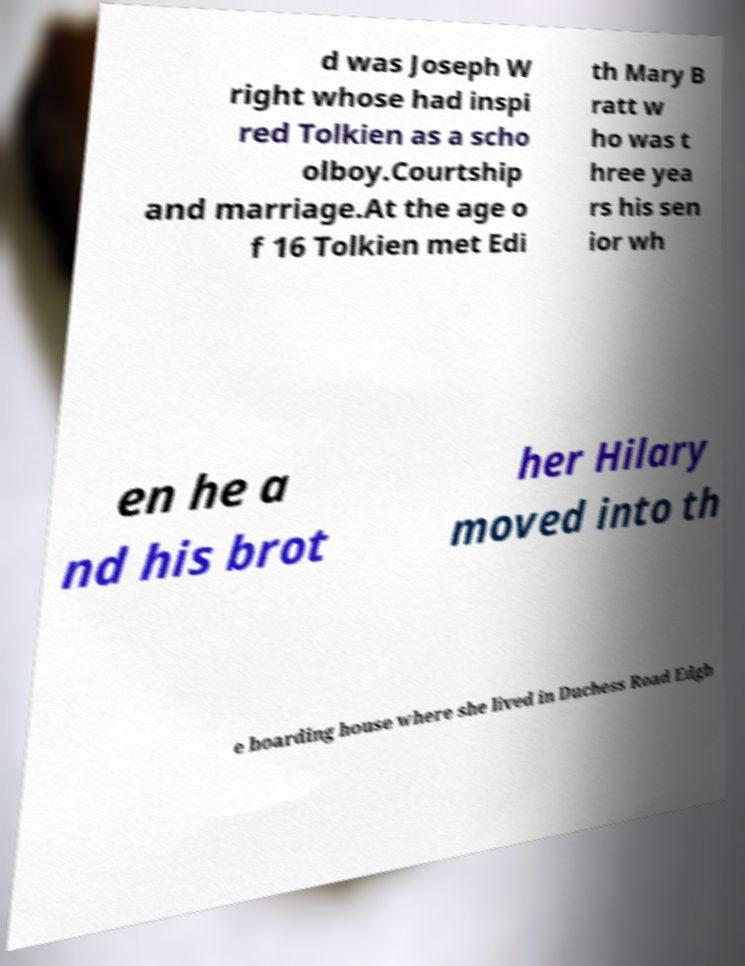Could you extract and type out the text from this image? d was Joseph W right whose had inspi red Tolkien as a scho olboy.Courtship and marriage.At the age o f 16 Tolkien met Edi th Mary B ratt w ho was t hree yea rs his sen ior wh en he a nd his brot her Hilary moved into th e boarding house where she lived in Duchess Road Edgb 